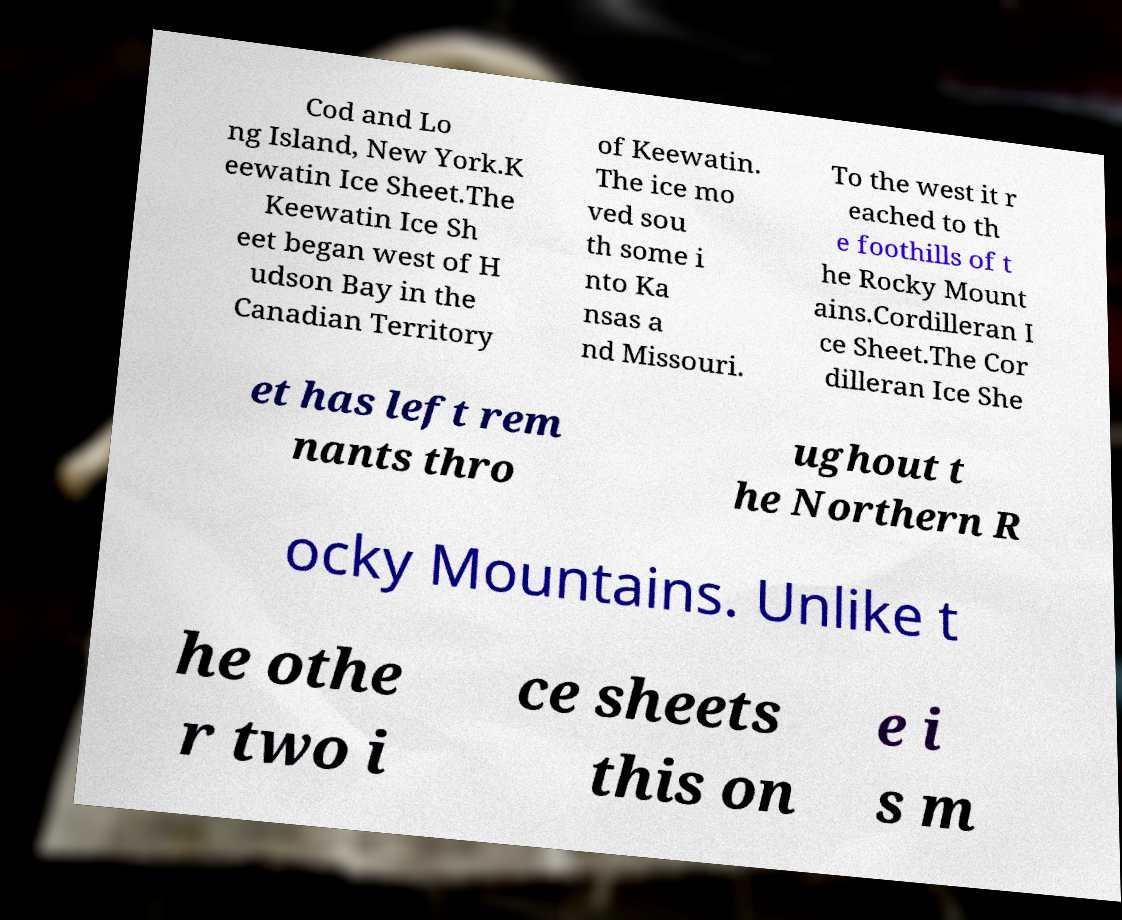For documentation purposes, I need the text within this image transcribed. Could you provide that? Cod and Lo ng Island, New York.K eewatin Ice Sheet.The Keewatin Ice Sh eet began west of H udson Bay in the Canadian Territory of Keewatin. The ice mo ved sou th some i nto Ka nsas a nd Missouri. To the west it r eached to th e foothills of t he Rocky Mount ains.Cordilleran I ce Sheet.The Cor dilleran Ice She et has left rem nants thro ughout t he Northern R ocky Mountains. Unlike t he othe r two i ce sheets this on e i s m 